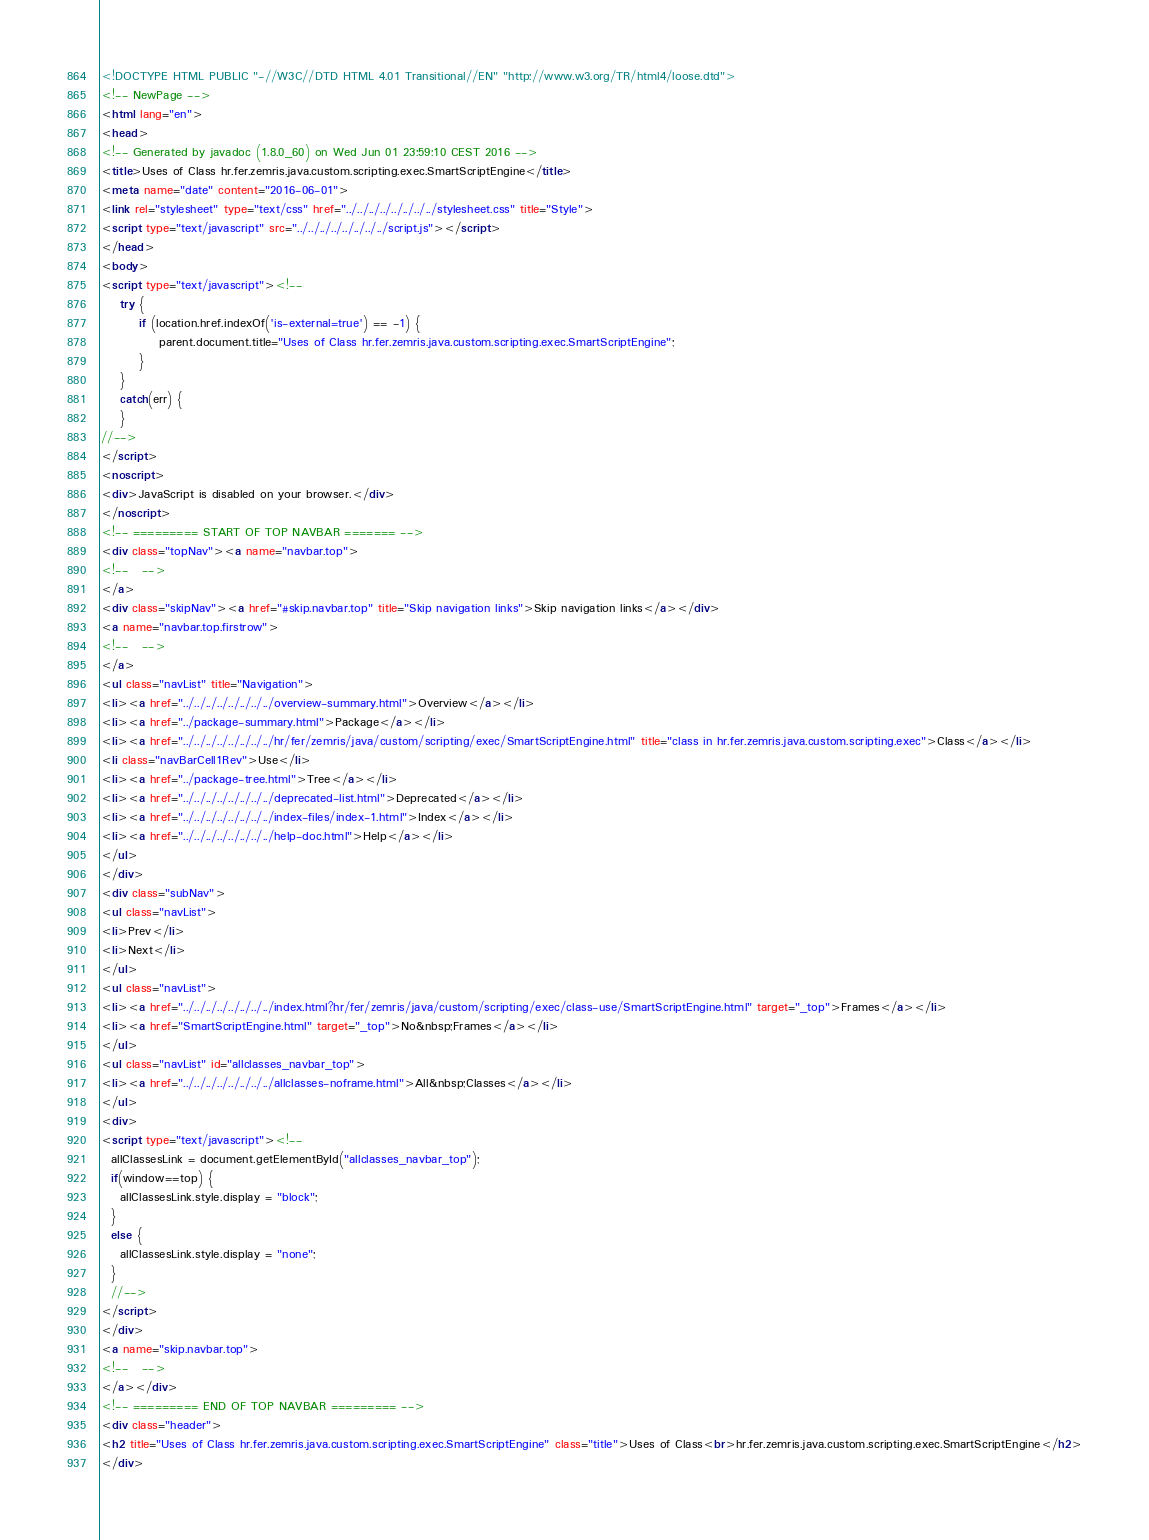<code> <loc_0><loc_0><loc_500><loc_500><_HTML_><!DOCTYPE HTML PUBLIC "-//W3C//DTD HTML 4.01 Transitional//EN" "http://www.w3.org/TR/html4/loose.dtd">
<!-- NewPage -->
<html lang="en">
<head>
<!-- Generated by javadoc (1.8.0_60) on Wed Jun 01 23:59:10 CEST 2016 -->
<title>Uses of Class hr.fer.zemris.java.custom.scripting.exec.SmartScriptEngine</title>
<meta name="date" content="2016-06-01">
<link rel="stylesheet" type="text/css" href="../../../../../../../../stylesheet.css" title="Style">
<script type="text/javascript" src="../../../../../../../../script.js"></script>
</head>
<body>
<script type="text/javascript"><!--
    try {
        if (location.href.indexOf('is-external=true') == -1) {
            parent.document.title="Uses of Class hr.fer.zemris.java.custom.scripting.exec.SmartScriptEngine";
        }
    }
    catch(err) {
    }
//-->
</script>
<noscript>
<div>JavaScript is disabled on your browser.</div>
</noscript>
<!-- ========= START OF TOP NAVBAR ======= -->
<div class="topNav"><a name="navbar.top">
<!--   -->
</a>
<div class="skipNav"><a href="#skip.navbar.top" title="Skip navigation links">Skip navigation links</a></div>
<a name="navbar.top.firstrow">
<!--   -->
</a>
<ul class="navList" title="Navigation">
<li><a href="../../../../../../../../overview-summary.html">Overview</a></li>
<li><a href="../package-summary.html">Package</a></li>
<li><a href="../../../../../../../../hr/fer/zemris/java/custom/scripting/exec/SmartScriptEngine.html" title="class in hr.fer.zemris.java.custom.scripting.exec">Class</a></li>
<li class="navBarCell1Rev">Use</li>
<li><a href="../package-tree.html">Tree</a></li>
<li><a href="../../../../../../../../deprecated-list.html">Deprecated</a></li>
<li><a href="../../../../../../../../index-files/index-1.html">Index</a></li>
<li><a href="../../../../../../../../help-doc.html">Help</a></li>
</ul>
</div>
<div class="subNav">
<ul class="navList">
<li>Prev</li>
<li>Next</li>
</ul>
<ul class="navList">
<li><a href="../../../../../../../../index.html?hr/fer/zemris/java/custom/scripting/exec/class-use/SmartScriptEngine.html" target="_top">Frames</a></li>
<li><a href="SmartScriptEngine.html" target="_top">No&nbsp;Frames</a></li>
</ul>
<ul class="navList" id="allclasses_navbar_top">
<li><a href="../../../../../../../../allclasses-noframe.html">All&nbsp;Classes</a></li>
</ul>
<div>
<script type="text/javascript"><!--
  allClassesLink = document.getElementById("allclasses_navbar_top");
  if(window==top) {
    allClassesLink.style.display = "block";
  }
  else {
    allClassesLink.style.display = "none";
  }
  //-->
</script>
</div>
<a name="skip.navbar.top">
<!--   -->
</a></div>
<!-- ========= END OF TOP NAVBAR ========= -->
<div class="header">
<h2 title="Uses of Class hr.fer.zemris.java.custom.scripting.exec.SmartScriptEngine" class="title">Uses of Class<br>hr.fer.zemris.java.custom.scripting.exec.SmartScriptEngine</h2>
</div></code> 